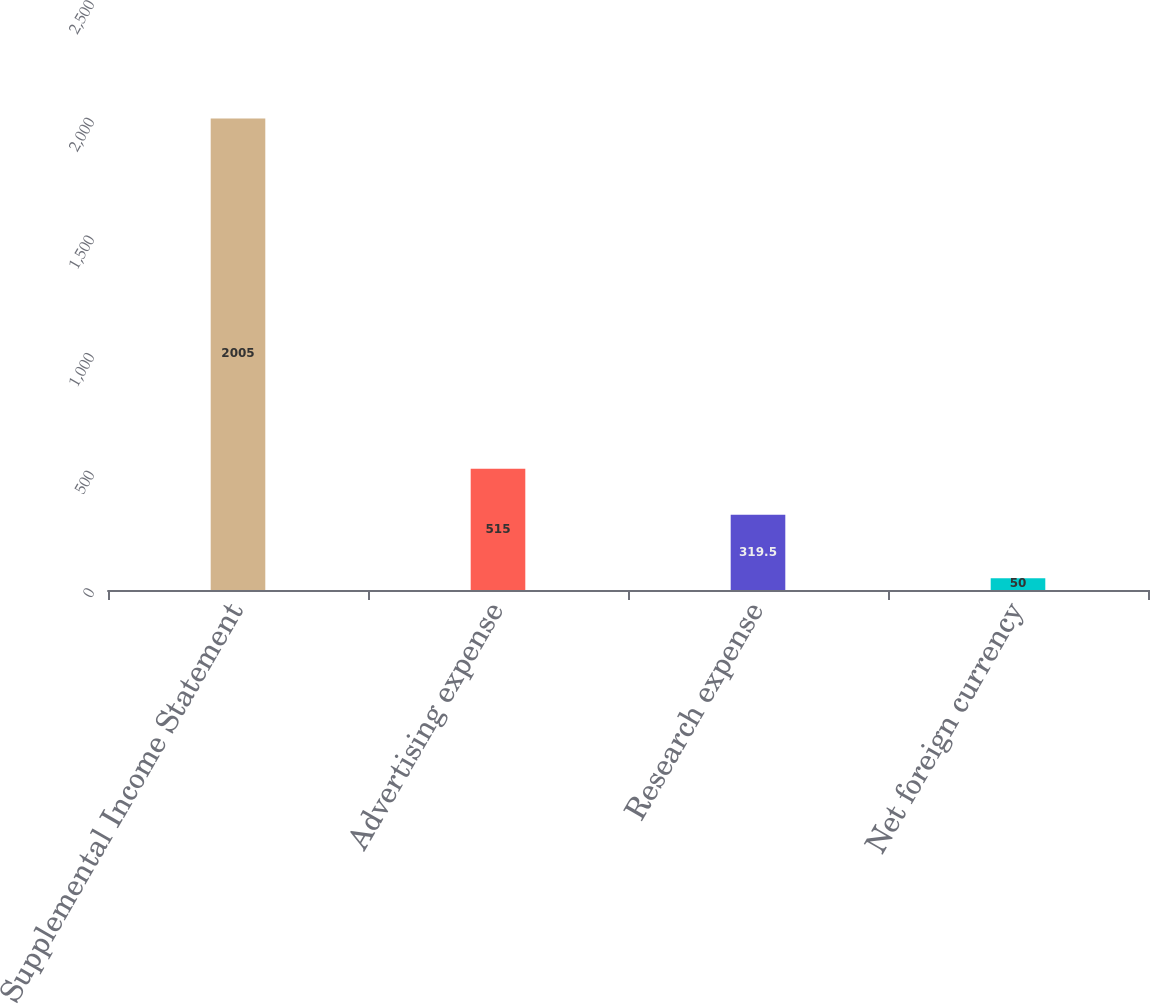<chart> <loc_0><loc_0><loc_500><loc_500><bar_chart><fcel>Supplemental Income Statement<fcel>Advertising expense<fcel>Research expense<fcel>Net foreign currency<nl><fcel>2005<fcel>515<fcel>319.5<fcel>50<nl></chart> 